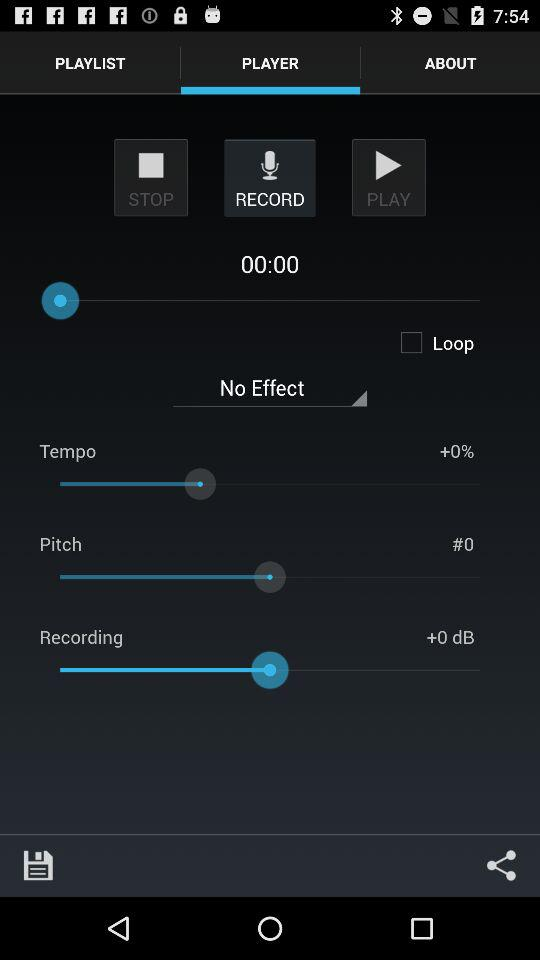What's the status of "Loop"? The status of "Loop" is "off". 